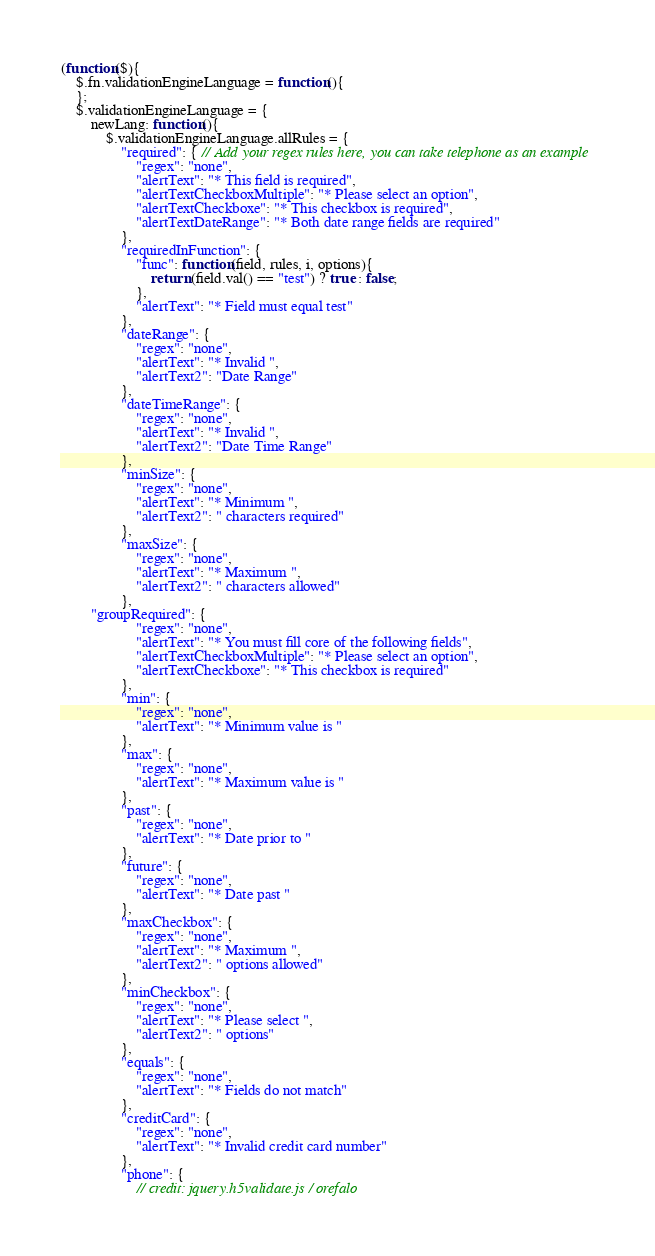<code> <loc_0><loc_0><loc_500><loc_500><_JavaScript_>(function($){
    $.fn.validationEngineLanguage = function(){
    };
    $.validationEngineLanguage = {
        newLang: function(){
            $.validationEngineLanguage.allRules = {
                "required": { // Add your regex rules here, you can take telephone as an example
                    "regex": "none",
                    "alertText": "* This field is required",
                    "alertTextCheckboxMultiple": "* Please select an option",
                    "alertTextCheckboxe": "* This checkbox is required",
                    "alertTextDateRange": "* Both date range fields are required"
                },
                "requiredInFunction": { 
                    "func": function(field, rules, i, options){
                        return (field.val() == "test") ? true : false;
                    },
                    "alertText": "* Field must equal test"
                },
                "dateRange": {
                    "regex": "none",
                    "alertText": "* Invalid ",
                    "alertText2": "Date Range"
                },
                "dateTimeRange": {
                    "regex": "none",
                    "alertText": "* Invalid ",
                    "alertText2": "Date Time Range"
                },
                "minSize": {
                    "regex": "none",
                    "alertText": "* Minimum ",
                    "alertText2": " characters required"
                },
                "maxSize": {
                    "regex": "none",
                    "alertText": "* Maximum ",
                    "alertText2": " characters allowed"
                },
		"groupRequired": {
                    "regex": "none",
                    "alertText": "* You must fill core of the following fields",
                    "alertTextCheckboxMultiple": "* Please select an option",
                    "alertTextCheckboxe": "* This checkbox is required"
                },
                "min": {
                    "regex": "none",
                    "alertText": "* Minimum value is "
                },
                "max": {
                    "regex": "none",
                    "alertText": "* Maximum value is "
                },
                "past": {
                    "regex": "none",
                    "alertText": "* Date prior to "
                },
                "future": {
                    "regex": "none",
                    "alertText": "* Date past "
                },	
                "maxCheckbox": {
                    "regex": "none",
                    "alertText": "* Maximum ",
                    "alertText2": " options allowed"
                },
                "minCheckbox": {
                    "regex": "none",
                    "alertText": "* Please select ",
                    "alertText2": " options"
                },
                "equals": {
                    "regex": "none",
                    "alertText": "* Fields do not match"
                },
                "creditCard": {
                    "regex": "none",
                    "alertText": "* Invalid credit card number"
                },
                "phone": {
                    // credit: jquery.h5validate.js / orefalo</code> 